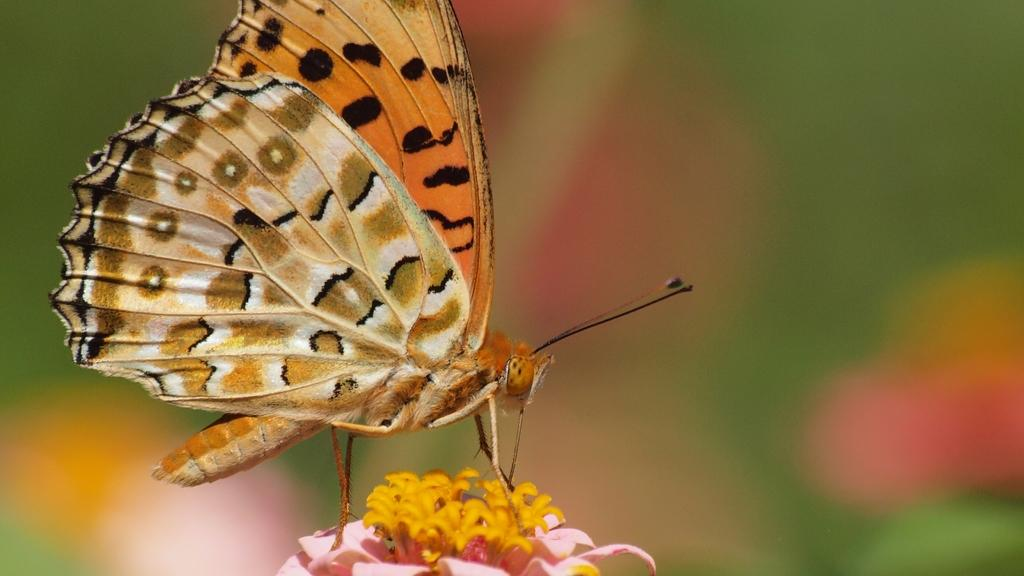What is the main subject of the image? There is a butterfly in the image. Where is the butterfly located? The butterfly is on a flower. Can you describe the background of the image? The background of the image is blurry. What type of book is the butterfly using to study for the test in the image? There is no book or test present in the image; it features a butterfly on a flower with a blurry background. 